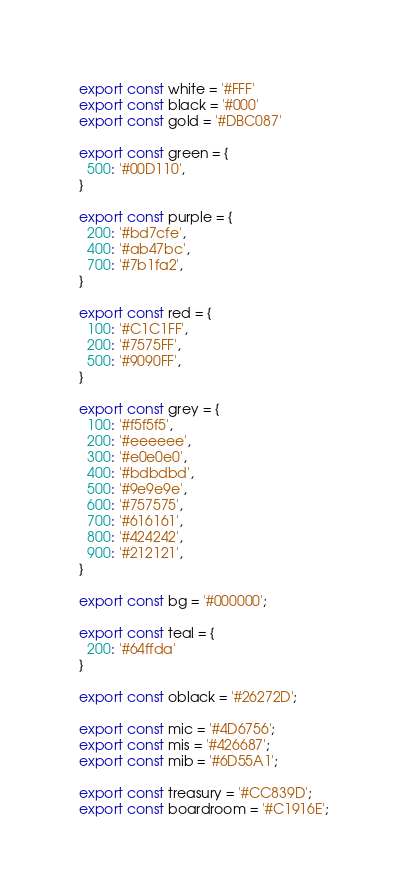<code> <loc_0><loc_0><loc_500><loc_500><_TypeScript_>export const white = '#FFF'
export const black = '#000'
export const gold = '#DBC087'

export const green = {
  500: '#00D110',
}

export const purple = {
  200: '#bd7cfe',
  400: '#ab47bc',
  700: '#7b1fa2',
}

export const red = {
  100: '#C1C1FF',
  200: '#7575FF',
  500: '#9090FF',
}

export const grey = {
  100: '#f5f5f5',
  200: '#eeeeee',
  300: '#e0e0e0',
  400: '#bdbdbd',
  500: '#9e9e9e',
  600: '#757575', 
  700: '#616161',
  800: '#424242',
  900: '#212121',
}

export const bg = '#000000';

export const teal = {
  200: '#64ffda'
}

export const oblack = '#26272D';

export const mic = '#4D6756';
export const mis = '#426687';
export const mib = '#6D55A1';

export const treasury = '#CC839D';
export const boardroom = '#C1916E';
</code> 